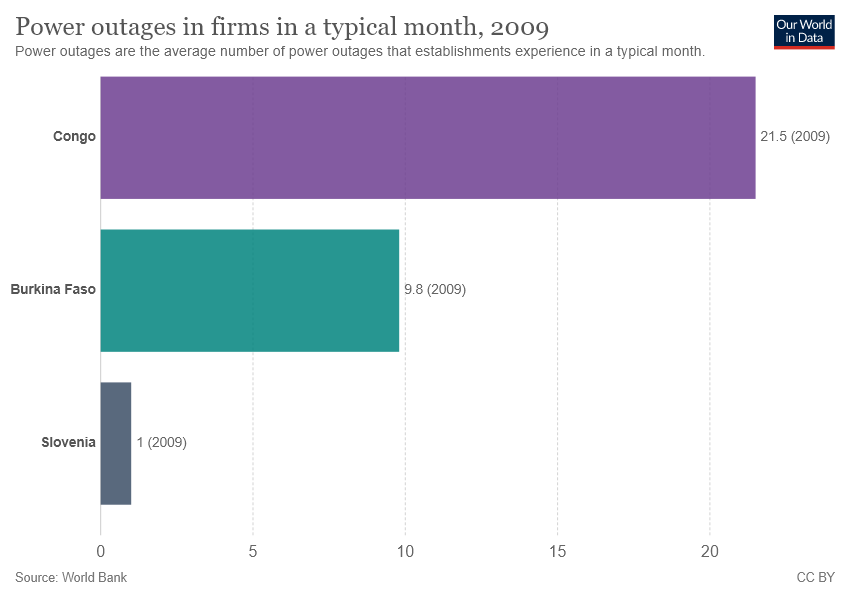Identify some key points in this picture. The country with the longest bar value is Congo. 